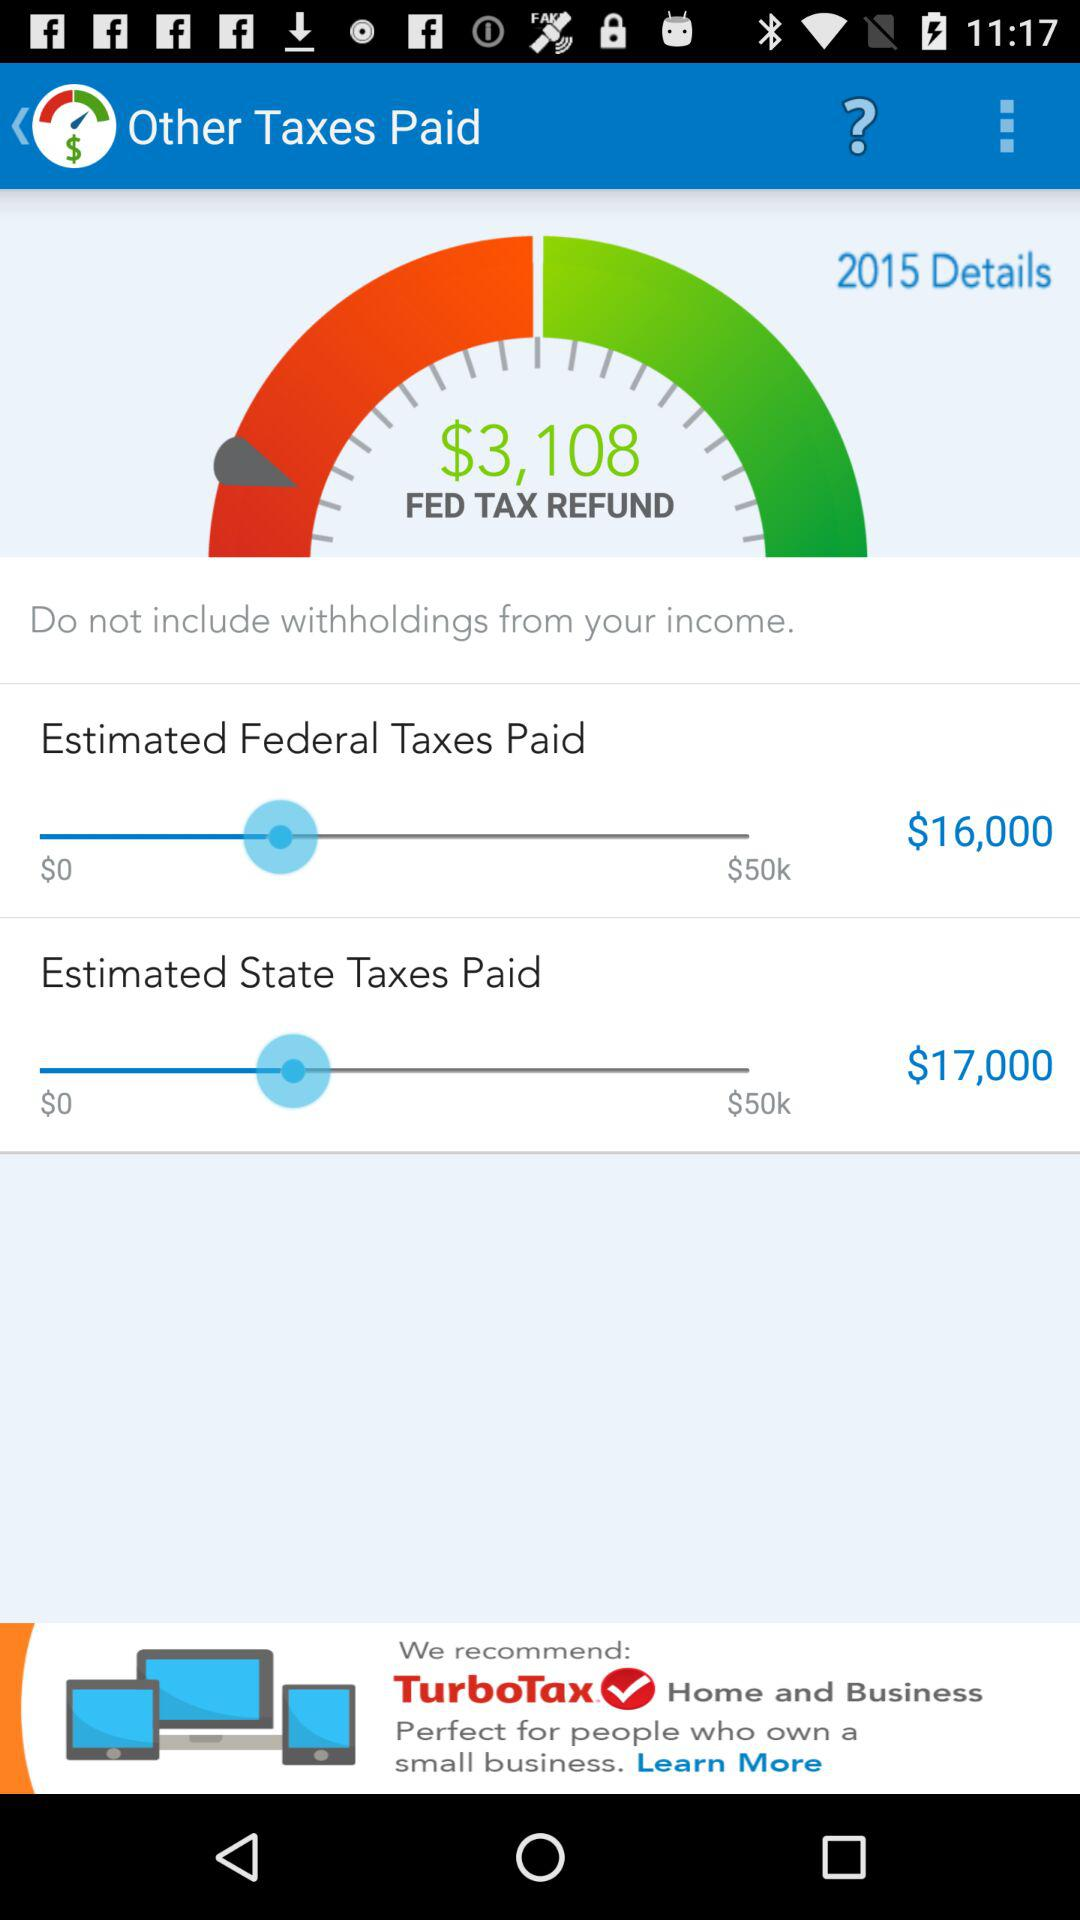How much more is the refund than the estimated taxes?
Answer the question using a single word or phrase. $3,108 